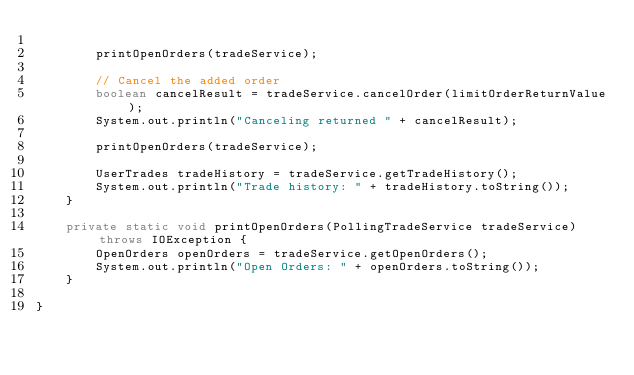Convert code to text. <code><loc_0><loc_0><loc_500><loc_500><_Java_>
        printOpenOrders(tradeService);

        // Cancel the added order
        boolean cancelResult = tradeService.cancelOrder(limitOrderReturnValue);
        System.out.println("Canceling returned " + cancelResult);

        printOpenOrders(tradeService);

        UserTrades tradeHistory = tradeService.getTradeHistory();
        System.out.println("Trade history: " + tradeHistory.toString());
    }

    private static void printOpenOrders(PollingTradeService tradeService) throws IOException {
        OpenOrders openOrders = tradeService.getOpenOrders();
        System.out.println("Open Orders: " + openOrders.toString());
    }

}
</code> 